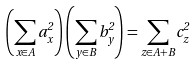<formula> <loc_0><loc_0><loc_500><loc_500>\left ( \sum _ { x \in A } a _ { x } ^ { 2 } \right ) \left ( \sum _ { y \in B } b _ { y } ^ { 2 } \right ) = \sum _ { z \in A + B } c _ { z } ^ { 2 }</formula> 